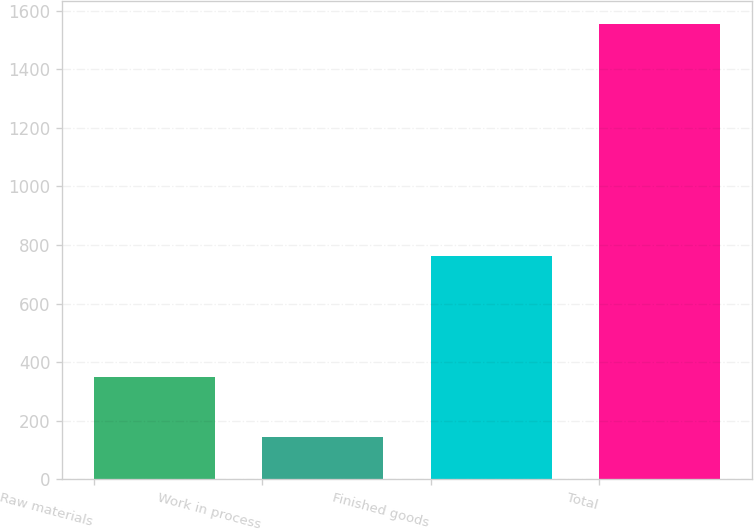Convert chart. <chart><loc_0><loc_0><loc_500><loc_500><bar_chart><fcel>Raw materials<fcel>Work in process<fcel>Finished goods<fcel>Total<nl><fcel>350<fcel>144<fcel>763<fcel>1555<nl></chart> 